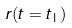Convert formula to latex. <formula><loc_0><loc_0><loc_500><loc_500>r ( t = t _ { 1 } )</formula> 